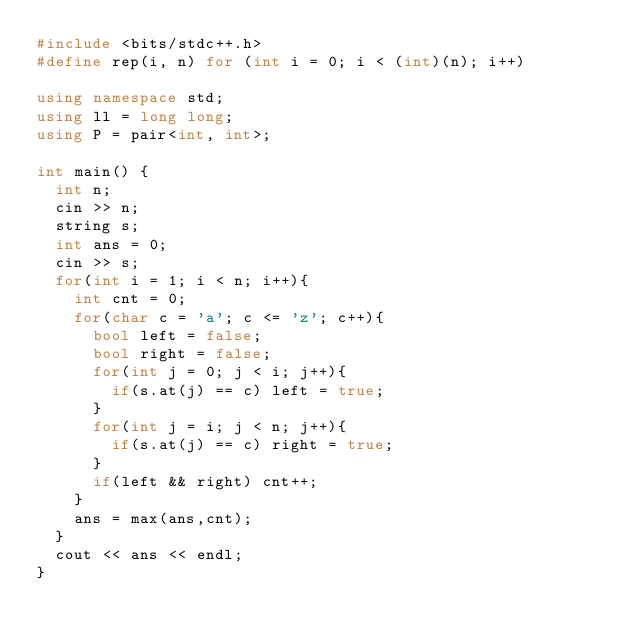Convert code to text. <code><loc_0><loc_0><loc_500><loc_500><_C++_>#include <bits/stdc++.h>
#define rep(i, n) for (int i = 0; i < (int)(n); i++)
 
using namespace std;
using ll = long long;
using P = pair<int, int>;

int main() {
  int n;
  cin >> n;
  string s;
  int ans = 0;
  cin >> s;
  for(int i = 1; i < n; i++){
    int cnt = 0;
    for(char c = 'a'; c <= 'z'; c++){
      bool left = false;
      bool right = false;
      for(int j = 0; j < i; j++){
        if(s.at(j) == c) left = true;
      }
      for(int j = i; j < n; j++){
        if(s.at(j) == c) right = true;
      }
      if(left && right) cnt++;
    }
    ans = max(ans,cnt);
  }
  cout << ans << endl;
}</code> 